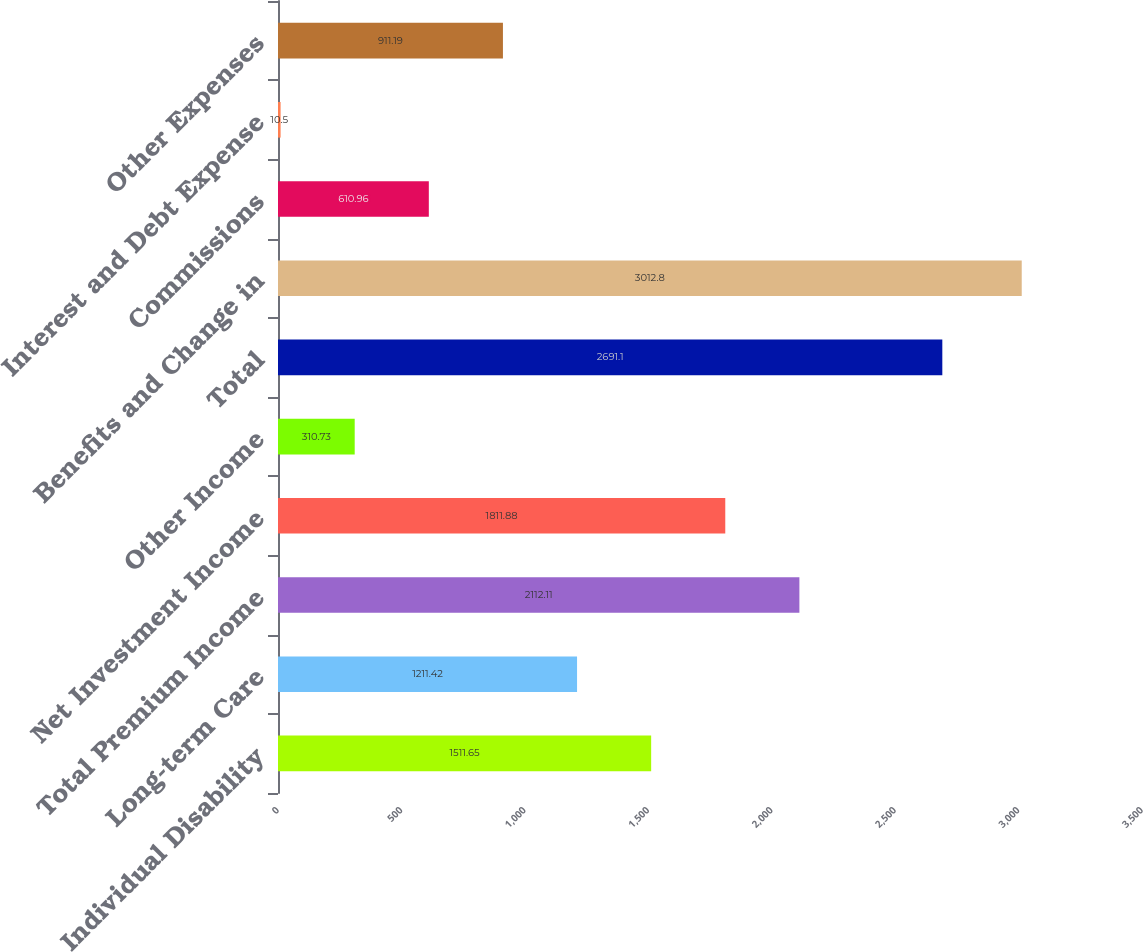Convert chart to OTSL. <chart><loc_0><loc_0><loc_500><loc_500><bar_chart><fcel>Individual Disability<fcel>Long-term Care<fcel>Total Premium Income<fcel>Net Investment Income<fcel>Other Income<fcel>Total<fcel>Benefits and Change in<fcel>Commissions<fcel>Interest and Debt Expense<fcel>Other Expenses<nl><fcel>1511.65<fcel>1211.42<fcel>2112.11<fcel>1811.88<fcel>310.73<fcel>2691.1<fcel>3012.8<fcel>610.96<fcel>10.5<fcel>911.19<nl></chart> 